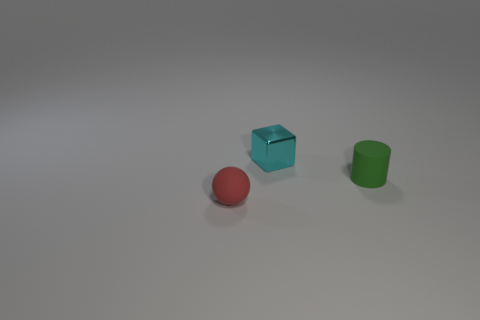What number of objects are either tiny objects or cylinders?
Provide a short and direct response. 3. Is the size of the matte thing left of the metallic object the same as the cyan object?
Provide a short and direct response. Yes. What number of other things are the same shape as the tiny red matte thing?
Your response must be concise. 0. What number of other things are there of the same material as the small block
Keep it short and to the point. 0. What color is the thing that is to the left of the cylinder and behind the sphere?
Offer a very short reply. Cyan. How many objects are either things that are behind the small red object or red rubber objects?
Keep it short and to the point. 3. What number of objects are tiny matte things that are right of the cyan metallic block or tiny rubber things behind the tiny matte ball?
Offer a very short reply. 1. Is the number of tiny green matte objects that are right of the green object less than the number of big yellow shiny spheres?
Make the answer very short. No. Do the tiny sphere and the small object behind the small matte cylinder have the same material?
Your answer should be very brief. No. What is the small cyan block made of?
Give a very brief answer. Metal. 